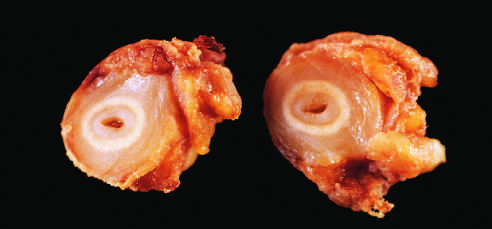do small intestine stem cells correspond to the original vessel wall?
Answer the question using a single word or phrase. No 